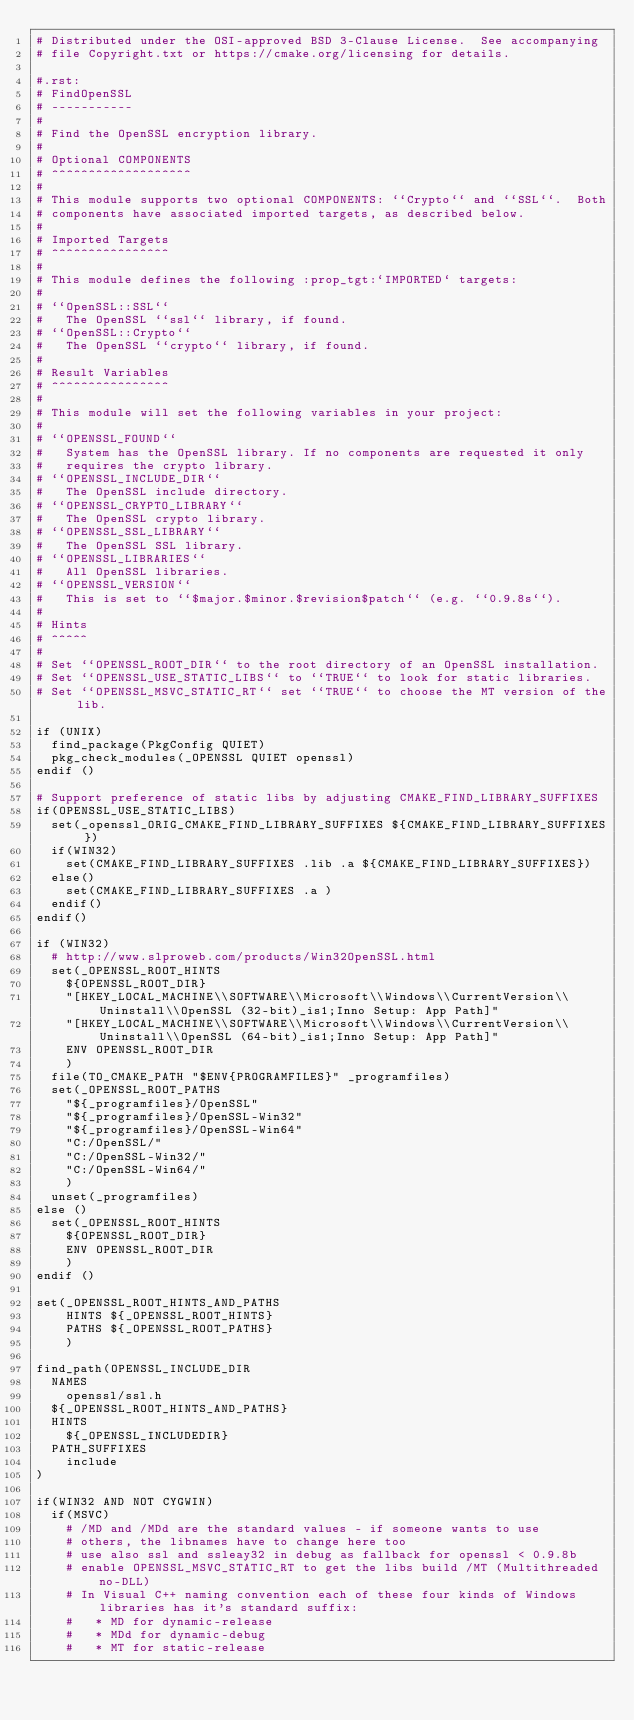<code> <loc_0><loc_0><loc_500><loc_500><_CMake_># Distributed under the OSI-approved BSD 3-Clause License.  See accompanying
# file Copyright.txt or https://cmake.org/licensing for details.

#.rst:
# FindOpenSSL
# -----------
#
# Find the OpenSSL encryption library.
#
# Optional COMPONENTS
# ^^^^^^^^^^^^^^^^^^^
#
# This module supports two optional COMPONENTS: ``Crypto`` and ``SSL``.  Both
# components have associated imported targets, as described below.
#
# Imported Targets
# ^^^^^^^^^^^^^^^^
#
# This module defines the following :prop_tgt:`IMPORTED` targets:
#
# ``OpenSSL::SSL``
#   The OpenSSL ``ssl`` library, if found.
# ``OpenSSL::Crypto``
#   The OpenSSL ``crypto`` library, if found.
#
# Result Variables
# ^^^^^^^^^^^^^^^^
#
# This module will set the following variables in your project:
#
# ``OPENSSL_FOUND``
#   System has the OpenSSL library. If no components are requested it only
#   requires the crypto library.
# ``OPENSSL_INCLUDE_DIR``
#   The OpenSSL include directory.
# ``OPENSSL_CRYPTO_LIBRARY``
#   The OpenSSL crypto library.
# ``OPENSSL_SSL_LIBRARY``
#   The OpenSSL SSL library.
# ``OPENSSL_LIBRARIES``
#   All OpenSSL libraries.
# ``OPENSSL_VERSION``
#   This is set to ``$major.$minor.$revision$patch`` (e.g. ``0.9.8s``).
#
# Hints
# ^^^^^
#
# Set ``OPENSSL_ROOT_DIR`` to the root directory of an OpenSSL installation.
# Set ``OPENSSL_USE_STATIC_LIBS`` to ``TRUE`` to look for static libraries.
# Set ``OPENSSL_MSVC_STATIC_RT`` set ``TRUE`` to choose the MT version of the lib.

if (UNIX)
  find_package(PkgConfig QUIET)
  pkg_check_modules(_OPENSSL QUIET openssl)
endif ()

# Support preference of static libs by adjusting CMAKE_FIND_LIBRARY_SUFFIXES
if(OPENSSL_USE_STATIC_LIBS)
  set(_openssl_ORIG_CMAKE_FIND_LIBRARY_SUFFIXES ${CMAKE_FIND_LIBRARY_SUFFIXES})
  if(WIN32)
    set(CMAKE_FIND_LIBRARY_SUFFIXES .lib .a ${CMAKE_FIND_LIBRARY_SUFFIXES})
  else()
    set(CMAKE_FIND_LIBRARY_SUFFIXES .a )
  endif()
endif()

if (WIN32)
  # http://www.slproweb.com/products/Win32OpenSSL.html
  set(_OPENSSL_ROOT_HINTS
    ${OPENSSL_ROOT_DIR}
    "[HKEY_LOCAL_MACHINE\\SOFTWARE\\Microsoft\\Windows\\CurrentVersion\\Uninstall\\OpenSSL (32-bit)_is1;Inno Setup: App Path]"
    "[HKEY_LOCAL_MACHINE\\SOFTWARE\\Microsoft\\Windows\\CurrentVersion\\Uninstall\\OpenSSL (64-bit)_is1;Inno Setup: App Path]"
    ENV OPENSSL_ROOT_DIR
    )
  file(TO_CMAKE_PATH "$ENV{PROGRAMFILES}" _programfiles)
  set(_OPENSSL_ROOT_PATHS
    "${_programfiles}/OpenSSL"
    "${_programfiles}/OpenSSL-Win32"
    "${_programfiles}/OpenSSL-Win64"
    "C:/OpenSSL/"
    "C:/OpenSSL-Win32/"
    "C:/OpenSSL-Win64/"
    )
  unset(_programfiles)
else ()
  set(_OPENSSL_ROOT_HINTS
    ${OPENSSL_ROOT_DIR}
    ENV OPENSSL_ROOT_DIR
    )
endif ()

set(_OPENSSL_ROOT_HINTS_AND_PATHS
    HINTS ${_OPENSSL_ROOT_HINTS}
    PATHS ${_OPENSSL_ROOT_PATHS}
    )

find_path(OPENSSL_INCLUDE_DIR
  NAMES
    openssl/ssl.h
  ${_OPENSSL_ROOT_HINTS_AND_PATHS}
  HINTS
    ${_OPENSSL_INCLUDEDIR}
  PATH_SUFFIXES
    include
)

if(WIN32 AND NOT CYGWIN)
  if(MSVC)
    # /MD and /MDd are the standard values - if someone wants to use
    # others, the libnames have to change here too
    # use also ssl and ssleay32 in debug as fallback for openssl < 0.9.8b
    # enable OPENSSL_MSVC_STATIC_RT to get the libs build /MT (Multithreaded no-DLL)
    # In Visual C++ naming convention each of these four kinds of Windows libraries has it's standard suffix:
    #   * MD for dynamic-release
    #   * MDd for dynamic-debug
    #   * MT for static-release</code> 